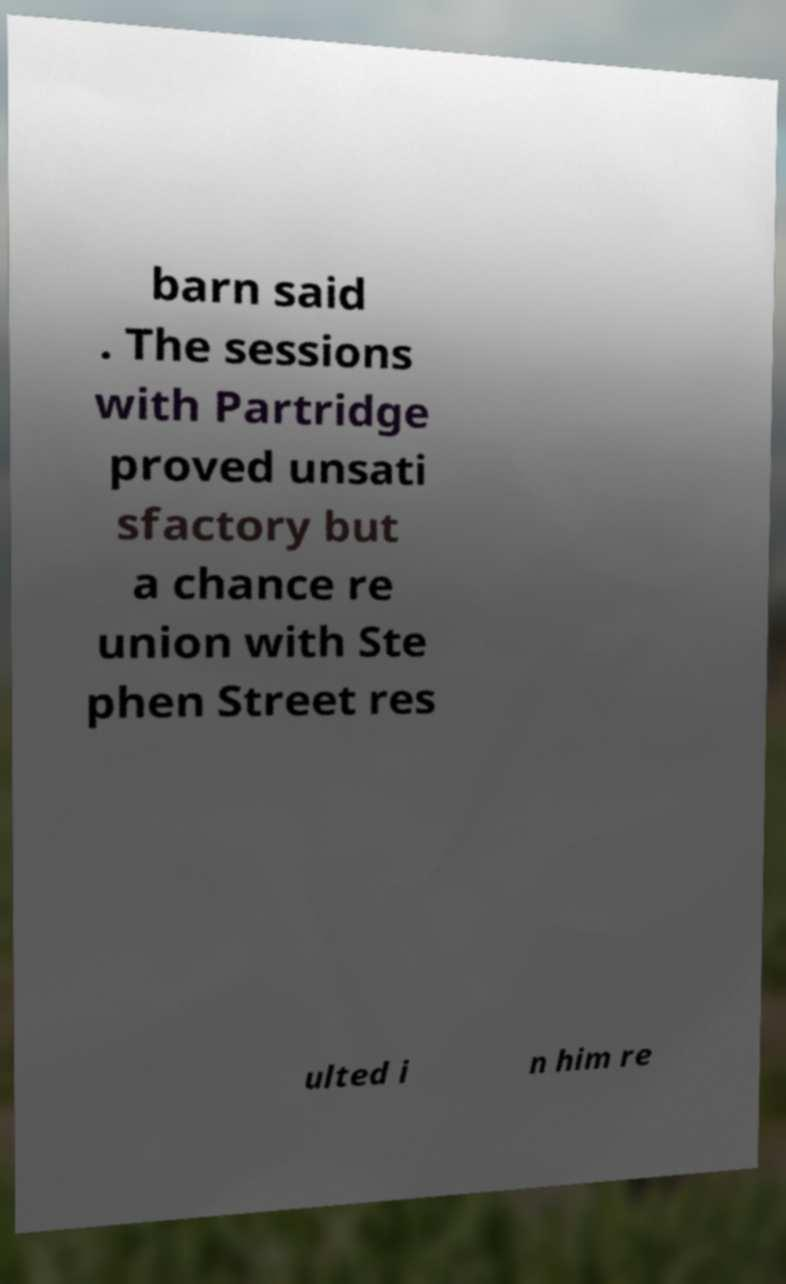Could you extract and type out the text from this image? barn said . The sessions with Partridge proved unsati sfactory but a chance re union with Ste phen Street res ulted i n him re 